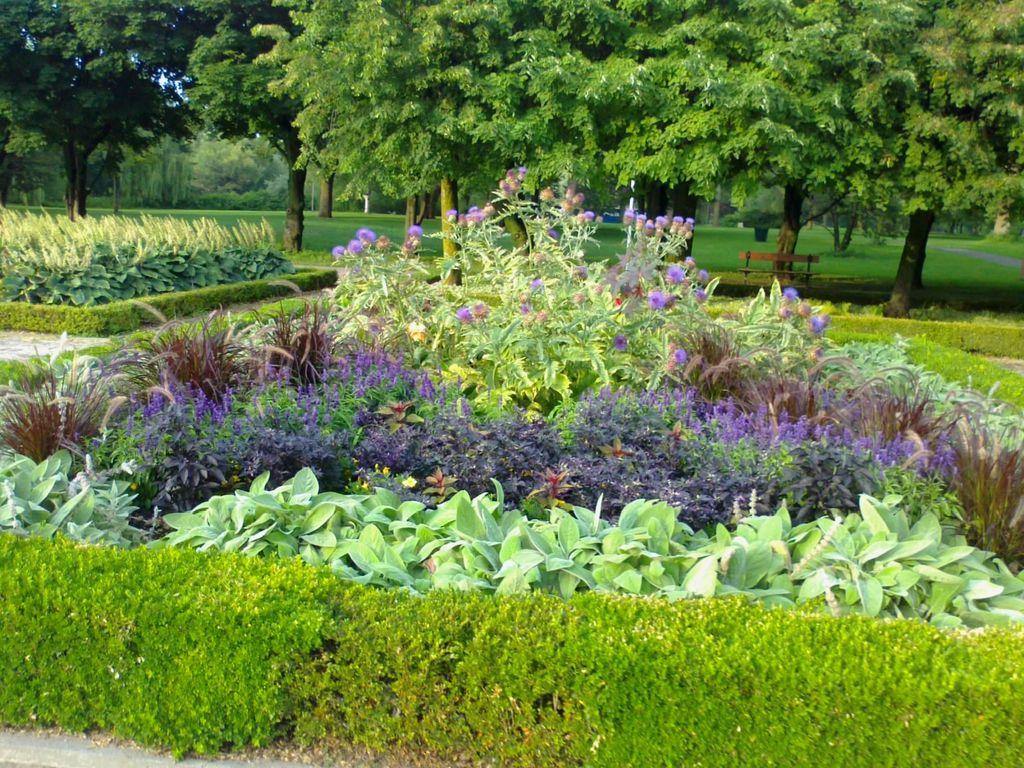Describe this image in one or two sentences. In this image at the bottom there are some plants and flowers, and in the background there are trees and grass and one bench. 